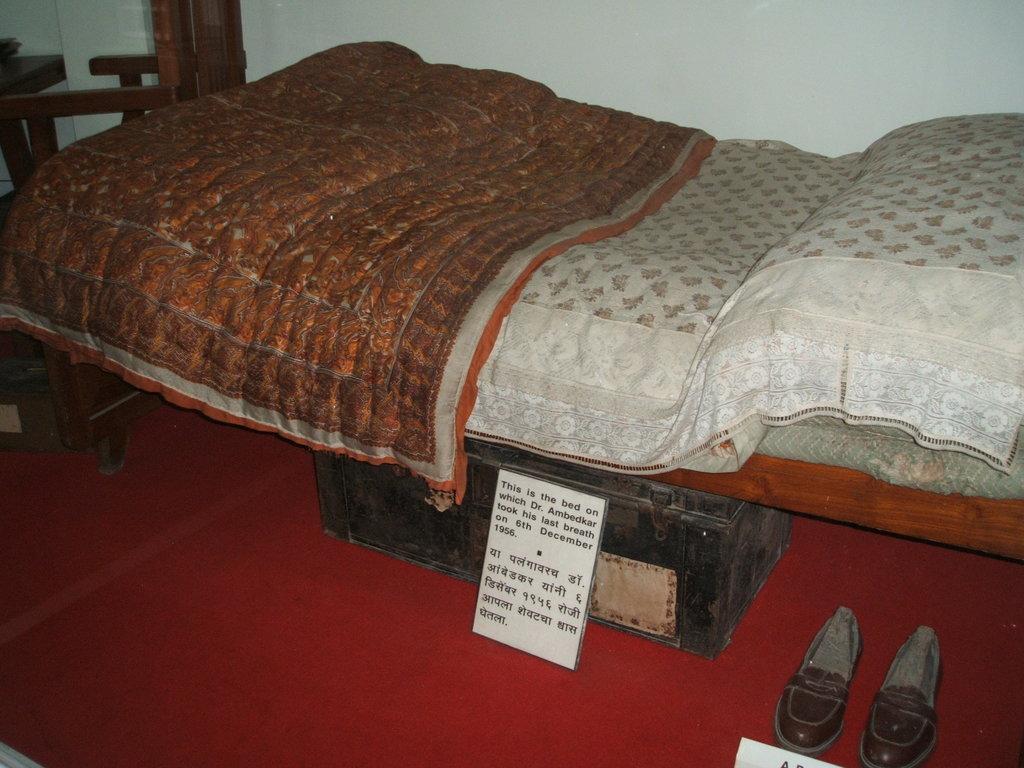In one or two sentences, can you explain what this image depicts? In this picture there is a bed. On the bed there is bed sheet, blanket and pillow. Below the bed there is a trunk and shoes beside it. In front of the trunk there is a small board with text on it. To the above left corner of the image there is a chair. There is carpet on the floor. In the background there is wall. 